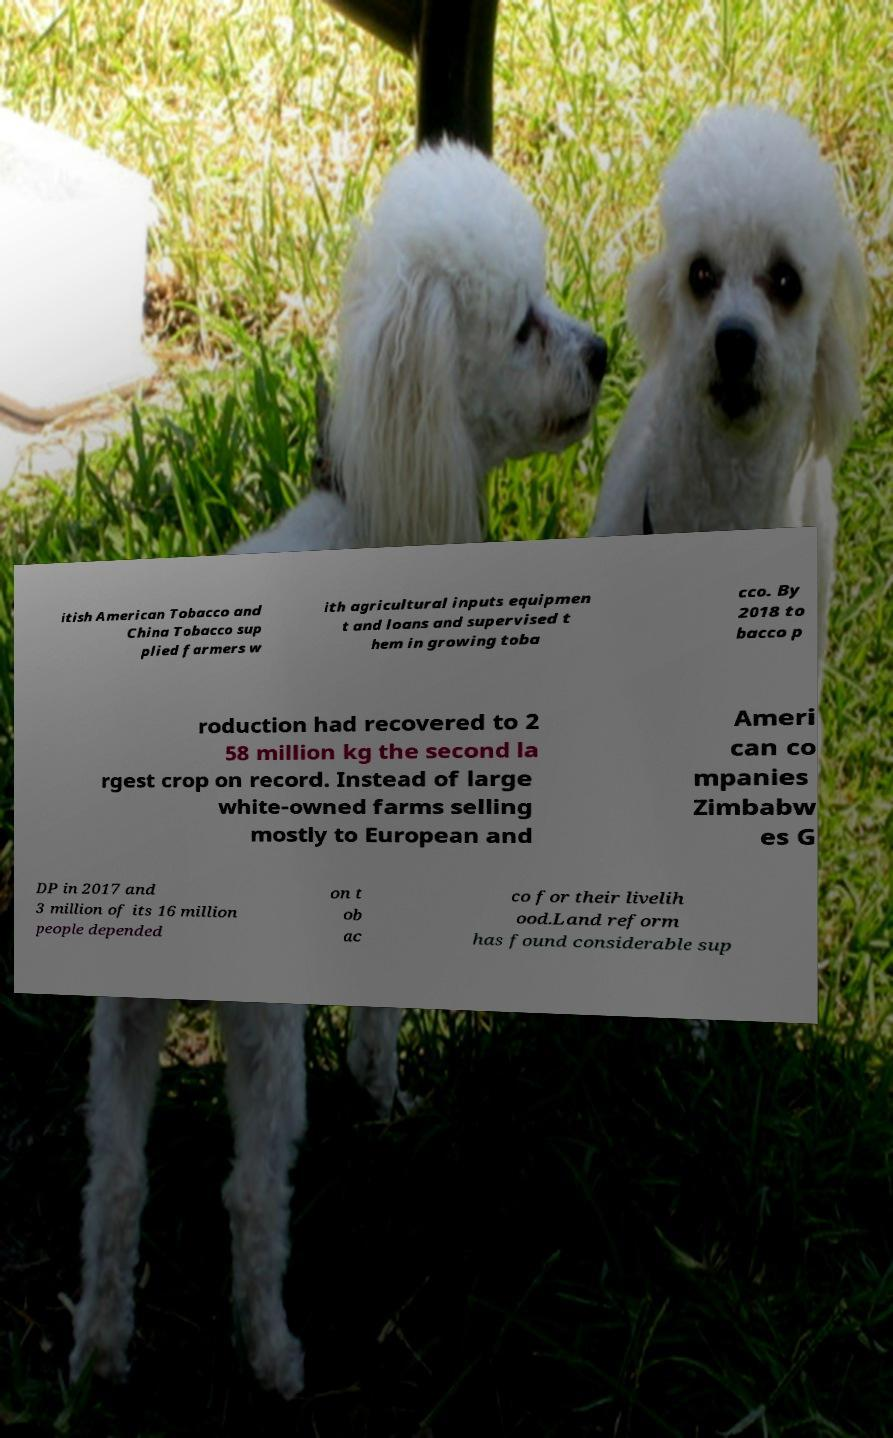Please read and relay the text visible in this image. What does it say? itish American Tobacco and China Tobacco sup plied farmers w ith agricultural inputs equipmen t and loans and supervised t hem in growing toba cco. By 2018 to bacco p roduction had recovered to 2 58 million kg the second la rgest crop on record. Instead of large white-owned farms selling mostly to European and Ameri can co mpanies Zimbabw es G DP in 2017 and 3 million of its 16 million people depended on t ob ac co for their livelih ood.Land reform has found considerable sup 